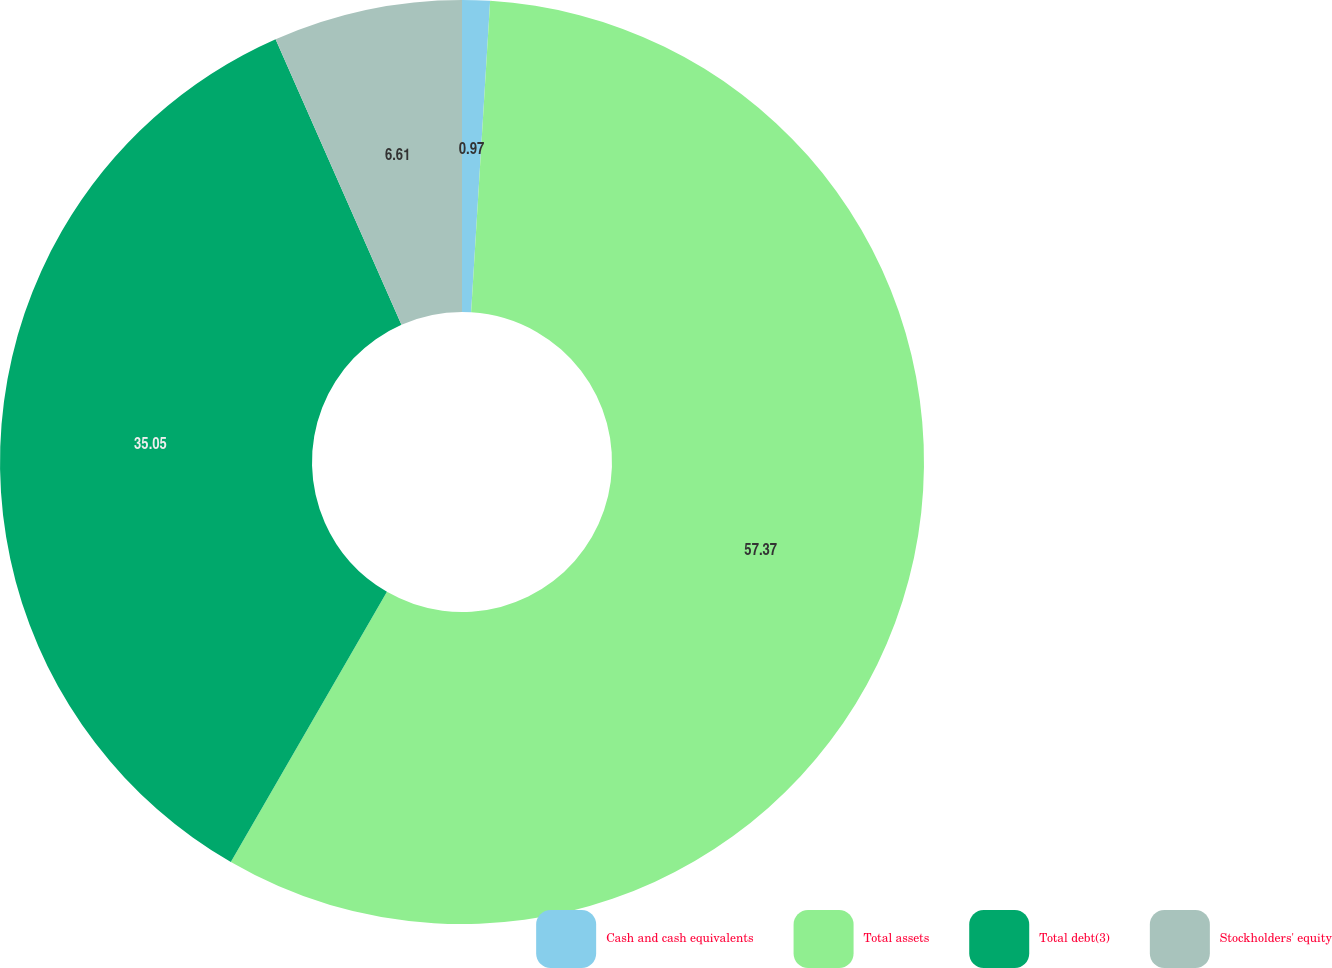Convert chart to OTSL. <chart><loc_0><loc_0><loc_500><loc_500><pie_chart><fcel>Cash and cash equivalents<fcel>Total assets<fcel>Total debt(3)<fcel>Stockholders' equity<nl><fcel>0.97%<fcel>57.37%<fcel>35.05%<fcel>6.61%<nl></chart> 